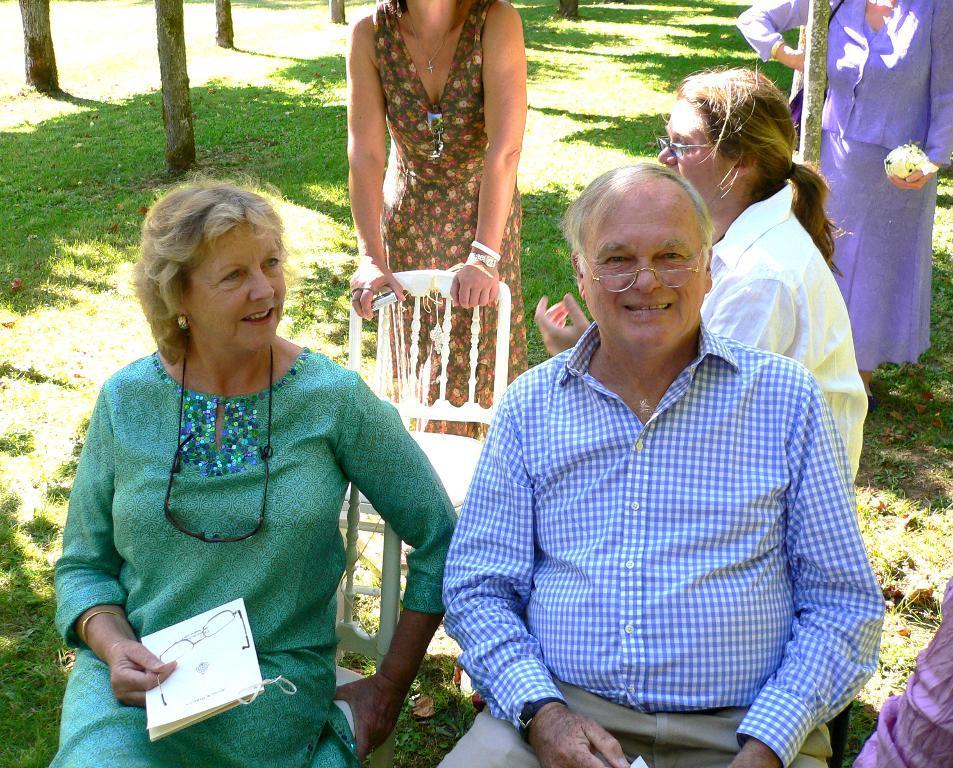Please provide a concise description of this image. In this picture there is a woman who is wearing green dress and holding a paper and spectacle. Beside her there is a man who is wearing spectacle, shirt, trouser and watch. Both of them are sitting on the chair. At the top there is a woman who is standing behind the chair. In the top right corner there are two persons. On the left I can see the green grass. 